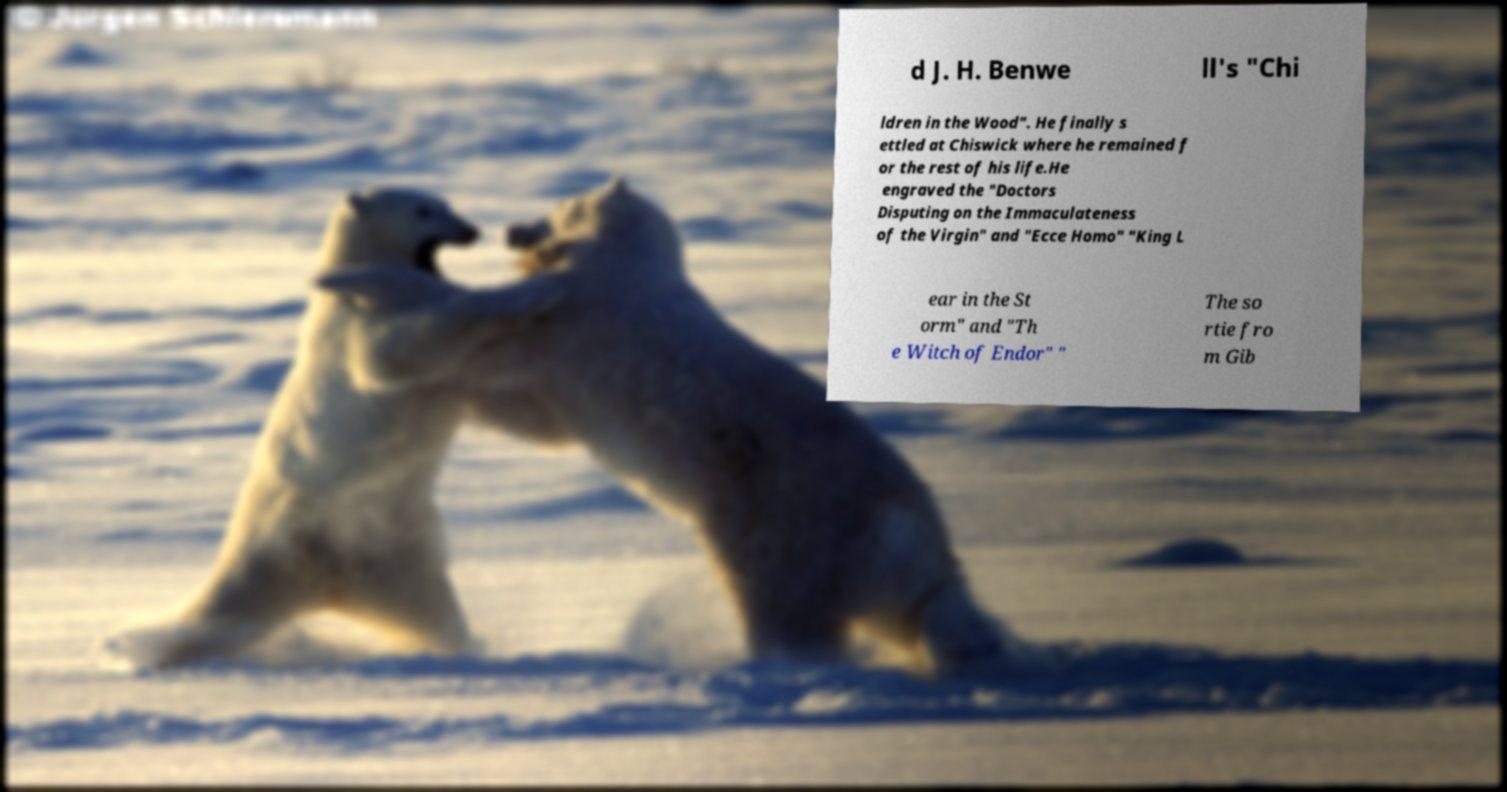Could you extract and type out the text from this image? d J. H. Benwe ll's "Chi ldren in the Wood". He finally s ettled at Chiswick where he remained f or the rest of his life.He engraved the "Doctors Disputing on the Immaculateness of the Virgin" and "Ecce Homo" "King L ear in the St orm" and "Th e Witch of Endor" " The so rtie fro m Gib 